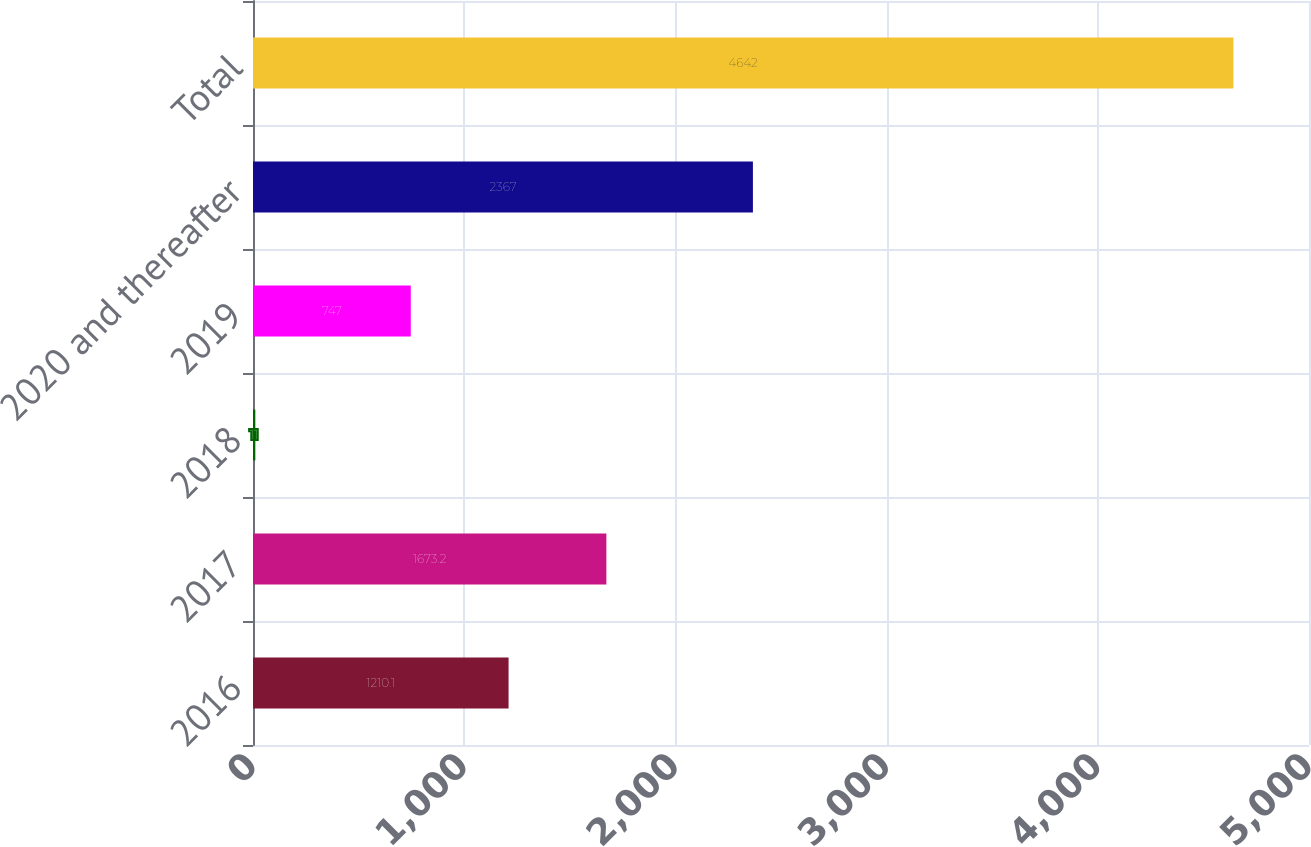Convert chart to OTSL. <chart><loc_0><loc_0><loc_500><loc_500><bar_chart><fcel>2016<fcel>2017<fcel>2018<fcel>2019<fcel>2020 and thereafter<fcel>Total<nl><fcel>1210.1<fcel>1673.2<fcel>11<fcel>747<fcel>2367<fcel>4642<nl></chart> 